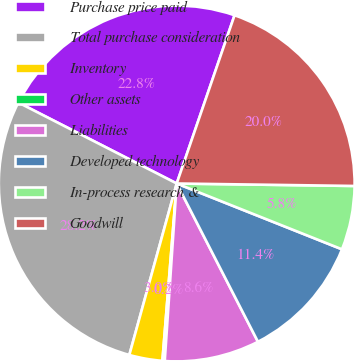Convert chart. <chart><loc_0><loc_0><loc_500><loc_500><pie_chart><fcel>Purchase price paid<fcel>Total purchase consideration<fcel>Inventory<fcel>Other assets<fcel>Liabilities<fcel>Developed technology<fcel>In-process research &<fcel>Goodwill<nl><fcel>22.75%<fcel>28.23%<fcel>3.01%<fcel>0.21%<fcel>8.62%<fcel>11.42%<fcel>5.81%<fcel>19.95%<nl></chart> 